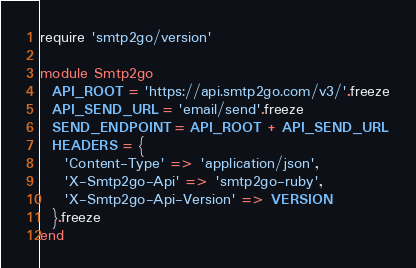Convert code to text. <code><loc_0><loc_0><loc_500><loc_500><_Ruby_>require 'smtp2go/version'

module Smtp2go
  API_ROOT = 'https://api.smtp2go.com/v3/'.freeze
  API_SEND_URL = 'email/send'.freeze
  SEND_ENDPOINT = API_ROOT + API_SEND_URL
  HEADERS = {
    'Content-Type' => 'application/json',
    'X-Smtp2go-Api' => 'smtp2go-ruby',
    'X-Smtp2go-Api-Version' => VERSION
  }.freeze
end
</code> 